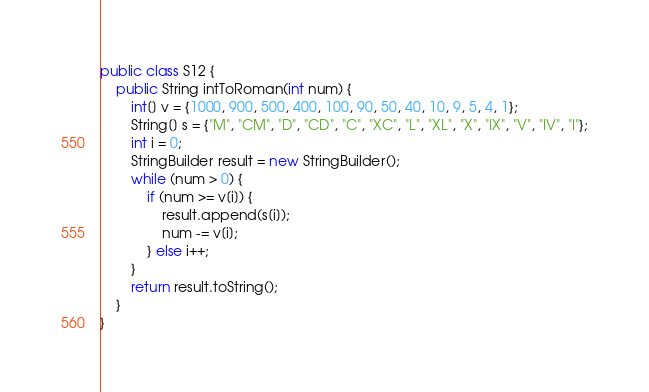<code> <loc_0><loc_0><loc_500><loc_500><_Java_>public class S12 {
    public String intToRoman(int num) {
        int[] v = {1000, 900, 500, 400, 100, 90, 50, 40, 10, 9, 5, 4, 1};
        String[] s = {"M", "CM", "D", "CD", "C", "XC", "L", "XL", "X", "IX", "V", "IV", "I"};
        int i = 0;
        StringBuilder result = new StringBuilder();
        while (num > 0) {
            if (num >= v[i]) {
                result.append(s[i]);
                num -= v[i];
            } else i++;
        }
        return result.toString();
    }
}
</code> 